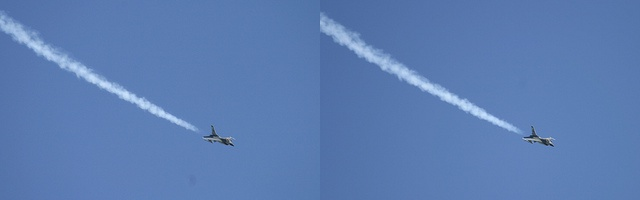Describe the objects in this image and their specific colors. I can see airplane in gray and darkgray tones and airplane in gray and darkgray tones in this image. 